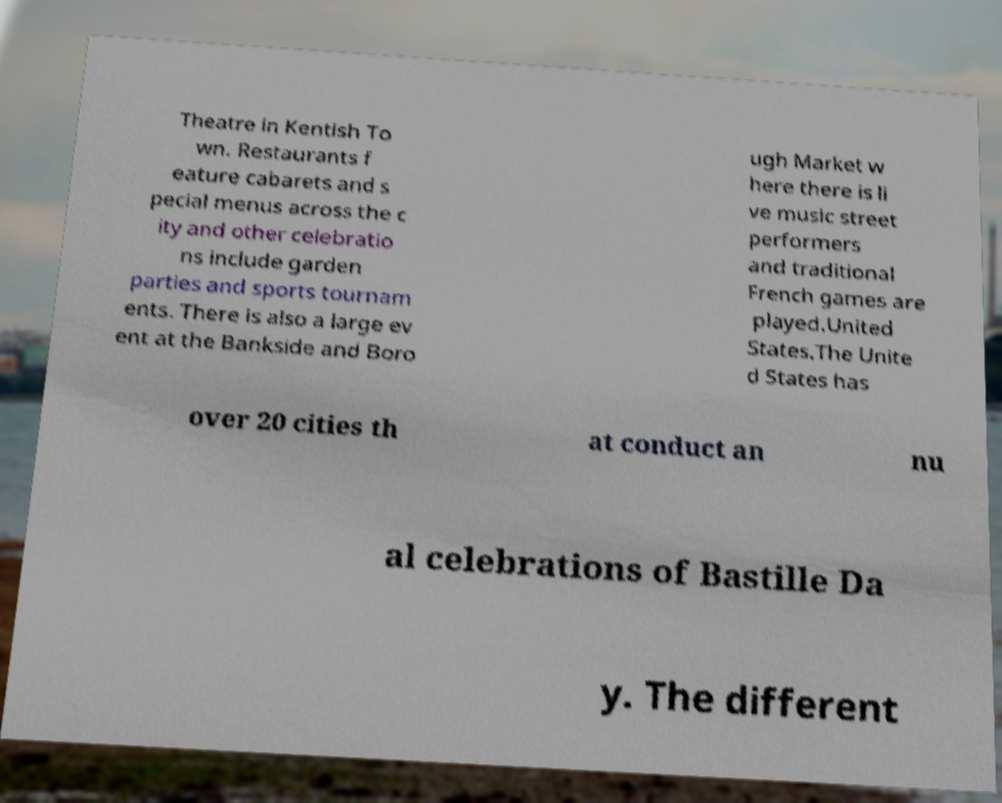Could you extract and type out the text from this image? Theatre in Kentish To wn. Restaurants f eature cabarets and s pecial menus across the c ity and other celebratio ns include garden parties and sports tournam ents. There is also a large ev ent at the Bankside and Boro ugh Market w here there is li ve music street performers and traditional French games are played.United States.The Unite d States has over 20 cities th at conduct an nu al celebrations of Bastille Da y. The different 